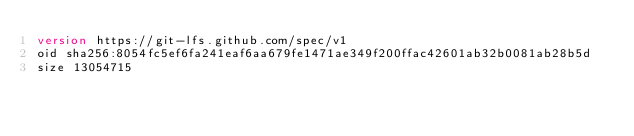<code> <loc_0><loc_0><loc_500><loc_500><_XML_>version https://git-lfs.github.com/spec/v1
oid sha256:8054fc5ef6fa241eaf6aa679fe1471ae349f200ffac42601ab32b0081ab28b5d
size 13054715
</code> 